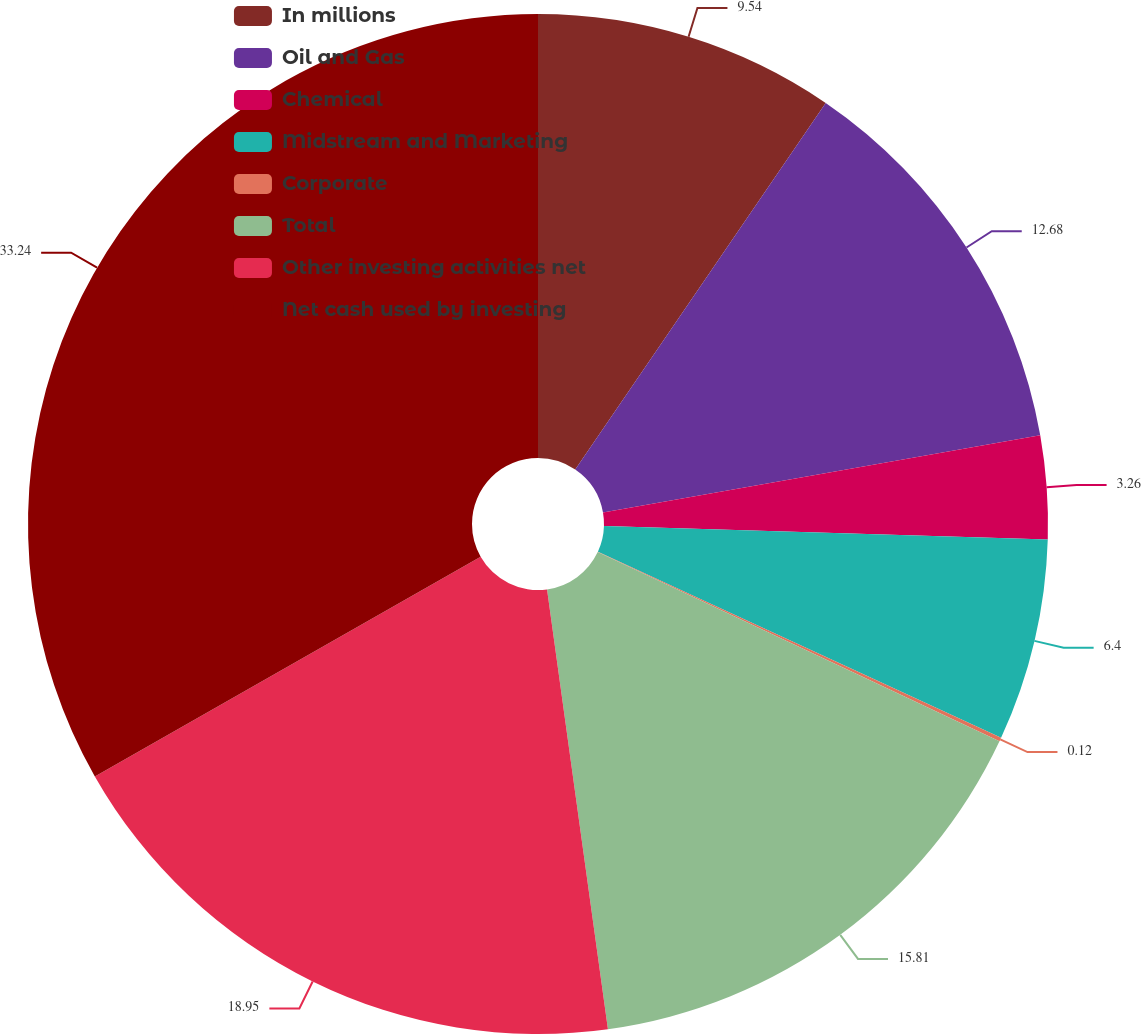Convert chart. <chart><loc_0><loc_0><loc_500><loc_500><pie_chart><fcel>In millions<fcel>Oil and Gas<fcel>Chemical<fcel>Midstream and Marketing<fcel>Corporate<fcel>Total<fcel>Other investing activities net<fcel>Net cash used by investing<nl><fcel>9.54%<fcel>12.68%<fcel>3.26%<fcel>6.4%<fcel>0.12%<fcel>15.81%<fcel>18.95%<fcel>33.24%<nl></chart> 